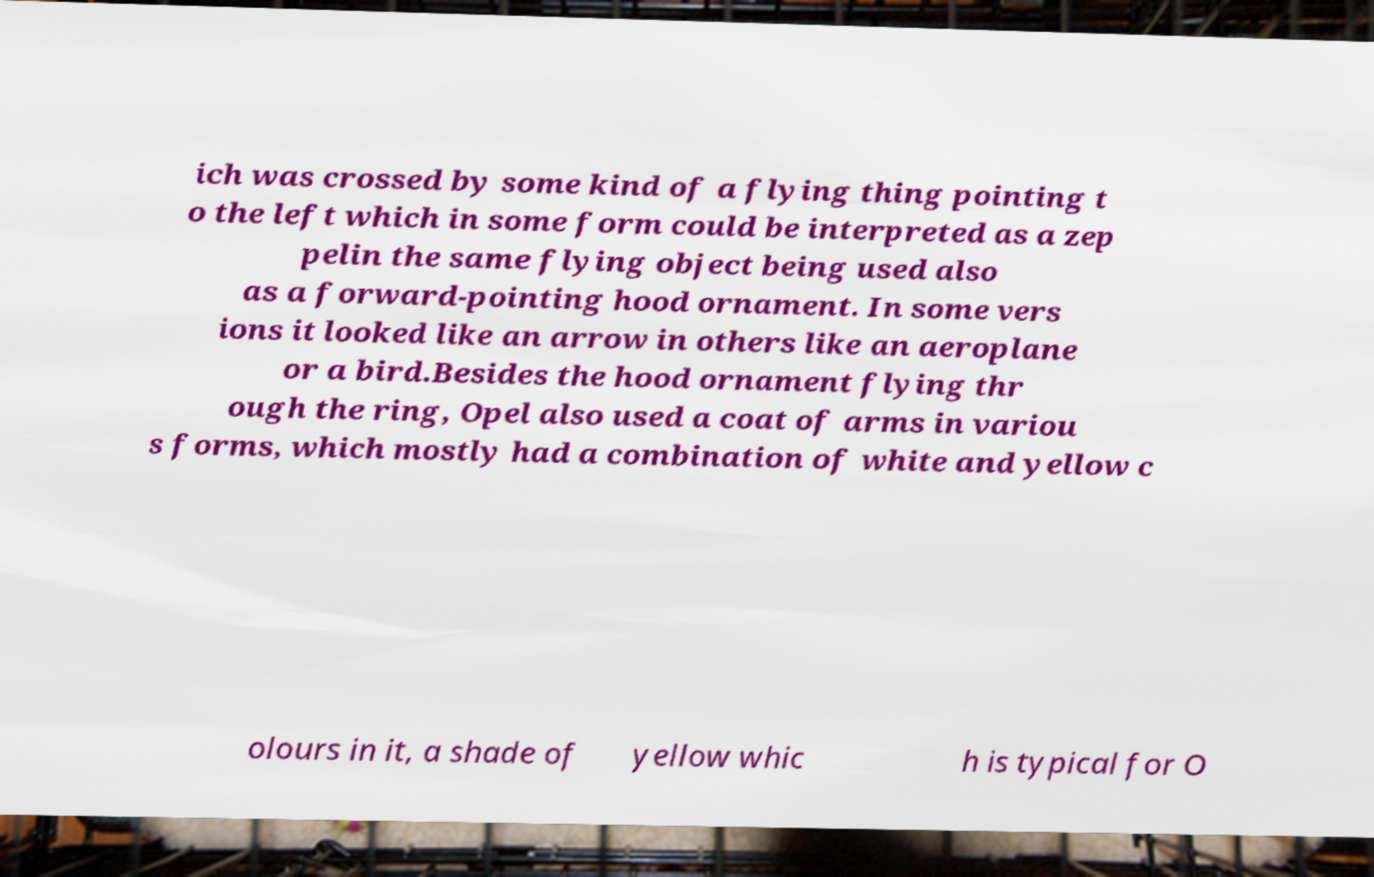Please read and relay the text visible in this image. What does it say? ich was crossed by some kind of a flying thing pointing t o the left which in some form could be interpreted as a zep pelin the same flying object being used also as a forward-pointing hood ornament. In some vers ions it looked like an arrow in others like an aeroplane or a bird.Besides the hood ornament flying thr ough the ring, Opel also used a coat of arms in variou s forms, which mostly had a combination of white and yellow c olours in it, a shade of yellow whic h is typical for O 